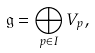<formula> <loc_0><loc_0><loc_500><loc_500>\mathfrak { g } = \bigoplus _ { p \in I } V _ { p } ,</formula> 